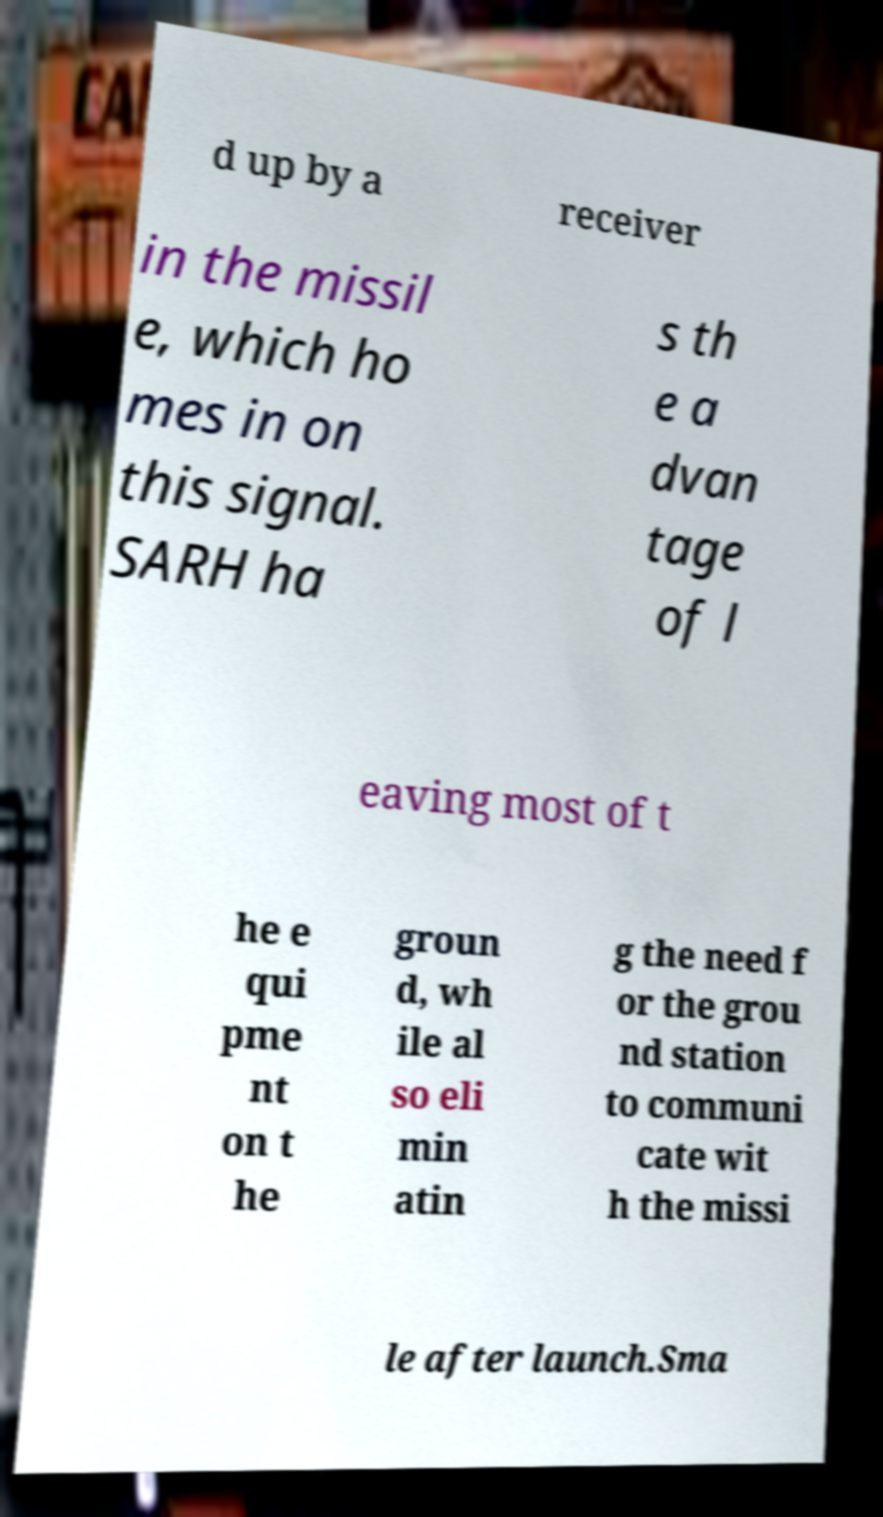Please read and relay the text visible in this image. What does it say? d up by a receiver in the missil e, which ho mes in on this signal. SARH ha s th e a dvan tage of l eaving most of t he e qui pme nt on t he groun d, wh ile al so eli min atin g the need f or the grou nd station to communi cate wit h the missi le after launch.Sma 